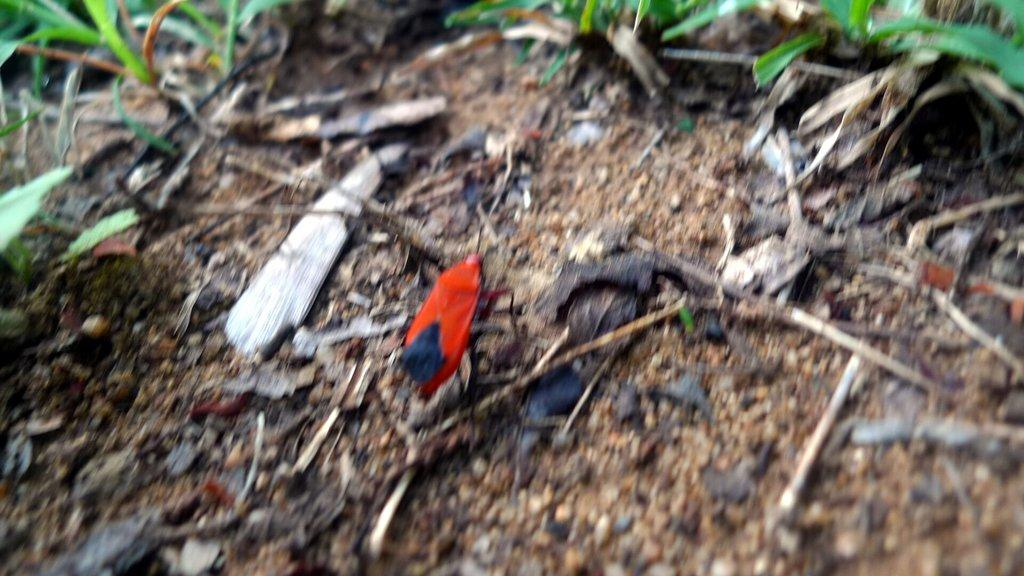What type of vegetation is present in the image? There is grass in the image. What type of living organism can be seen in the image? There is an insect in the image. What material are the pieces on the ground made of? The wooden pieces on the ground in the image are made of wood. What type of lettuce is being used to express anger in the image? There is no lettuce present in the image, and no expression of anger can be observed. 